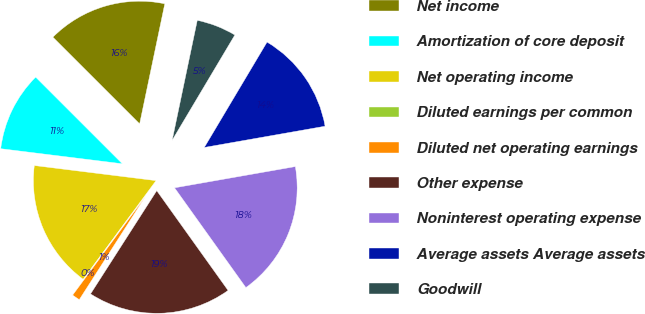Convert chart to OTSL. <chart><loc_0><loc_0><loc_500><loc_500><pie_chart><fcel>Net income<fcel>Amortization of core deposit<fcel>Net operating income<fcel>Diluted earnings per common<fcel>Diluted net operating earnings<fcel>Other expense<fcel>Noninterest operating expense<fcel>Average assets Average assets<fcel>Goodwill<nl><fcel>15.79%<fcel>10.53%<fcel>16.84%<fcel>0.0%<fcel>1.05%<fcel>18.95%<fcel>17.89%<fcel>13.68%<fcel>5.26%<nl></chart> 